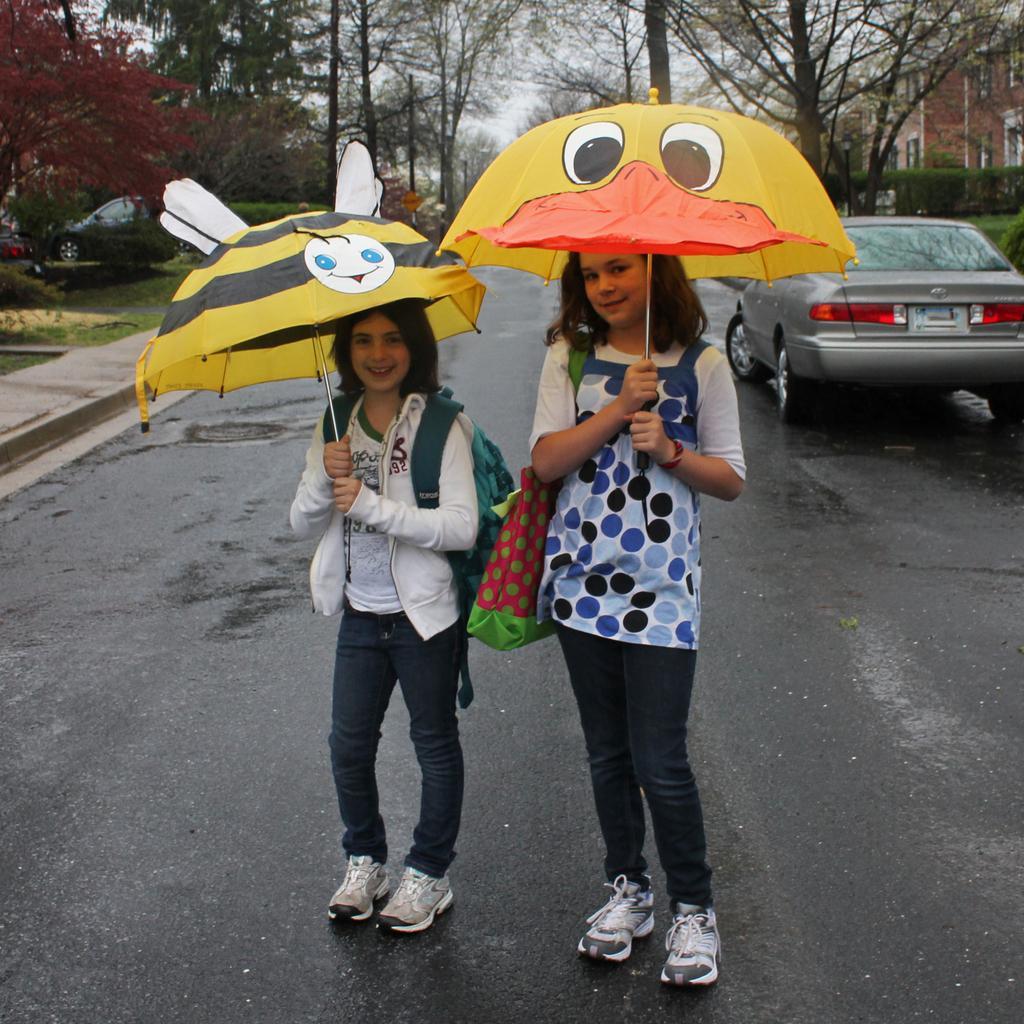How would you summarize this image in a sentence or two? In this picture we can see there are two girls standing on the road and the girls are holding the umbrellas. Behind the girls there are cars, trees, a building and the sky. 